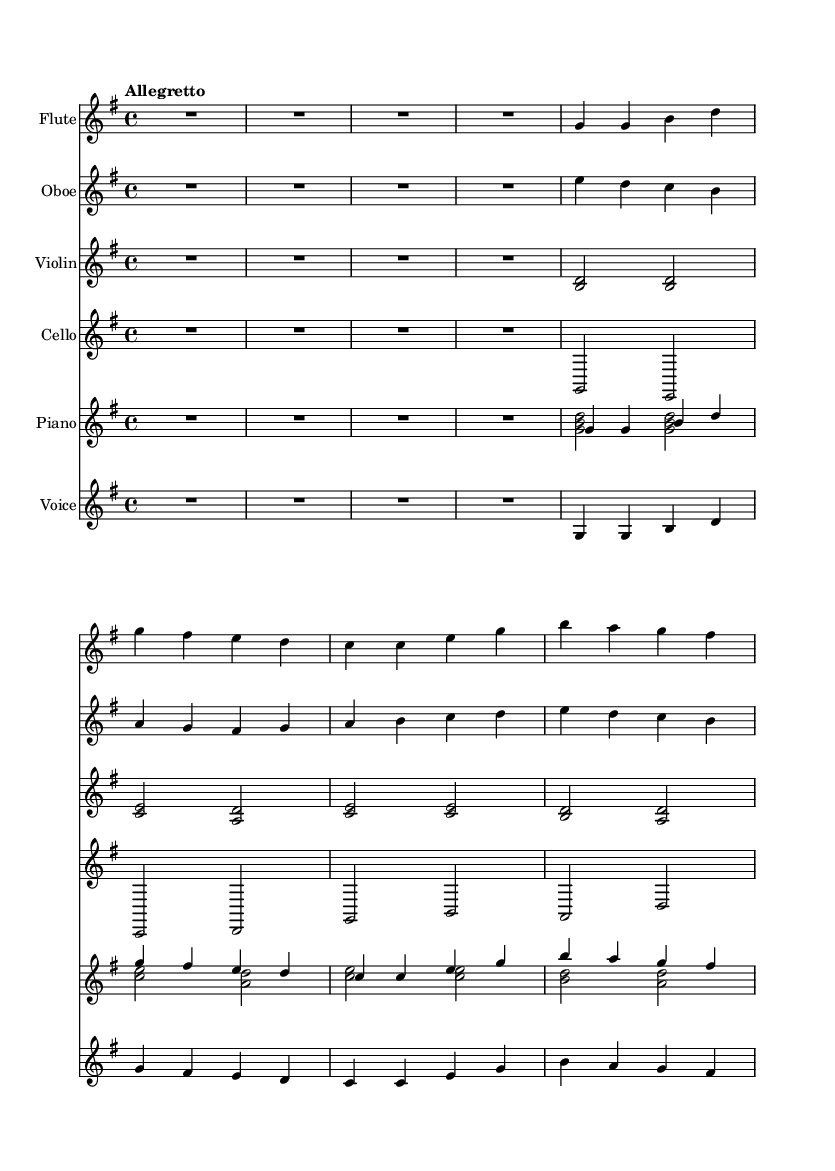What is the key signature of this music? The key signature is G major, which has one sharp (F#). This can be identified from the global section of the code where it is defined with "\key g \major".
Answer: G major What is the time signature of this piece? The time signature is 4/4, as stated in the global section of the code with "\time 4/4". This indicates four beats per measure.
Answer: 4/4 What is the tempo of this operetta? The tempo is marked as "Allegretto", which indicates a moderately fast speed. This is specified in the global section with "\tempo 'Allegretto'".
Answer: Allegretto How many measures are in this score? There are a total of six measures in this score. This can be counted by looking at the music notation for each instrument where the measures are divided by vertical bar lines.
Answer: Six What instruments are featured in this operetta? The instruments featured are flute, oboe, violin, cello, and piano. This information is provided in the score structure where each instrument is assigned its own staff.
Answer: Flute, oboe, violin, cello, piano What type of operetta is reflected in the lyrics? The lyrics reflect a theme of craftsmanship and creativity with a focus on building and using resources efficiently. This connection can be made from the lyrical content in the score: "With hammer and nail, I'll build it strong".
Answer: Craftsmanship What voice type is shown in this score? The voice type shown is labeled simply as "Voice". This is evident from the score structure where one staff is dedicated specifically to vocals.
Answer: Voice 